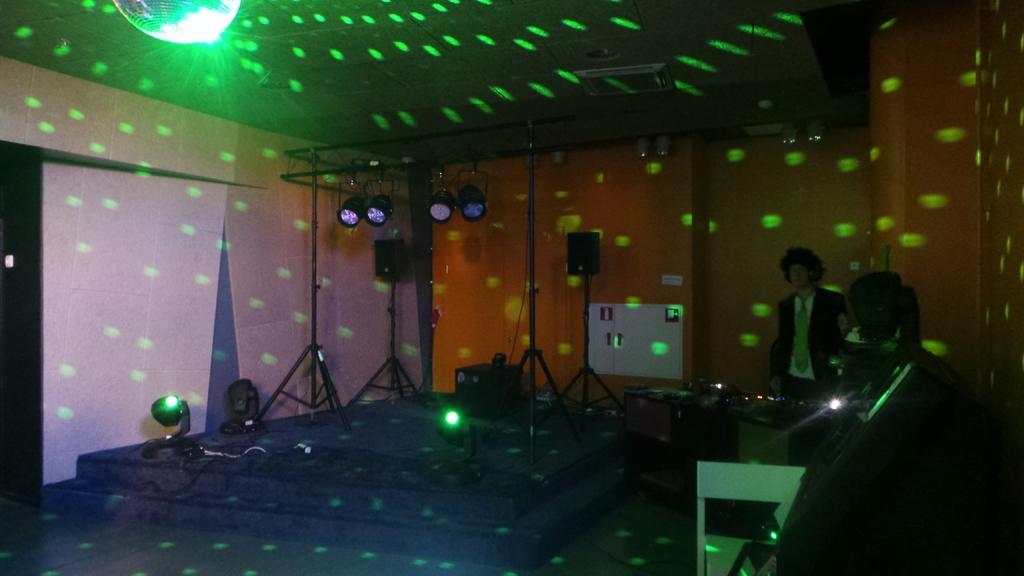In one or two sentences, can you explain what this image depicts? In this image, we can see some party lights. There is a person on the right side of the image wearing clothes and standing in front of the wall. There are some stands in the middle of the image. 